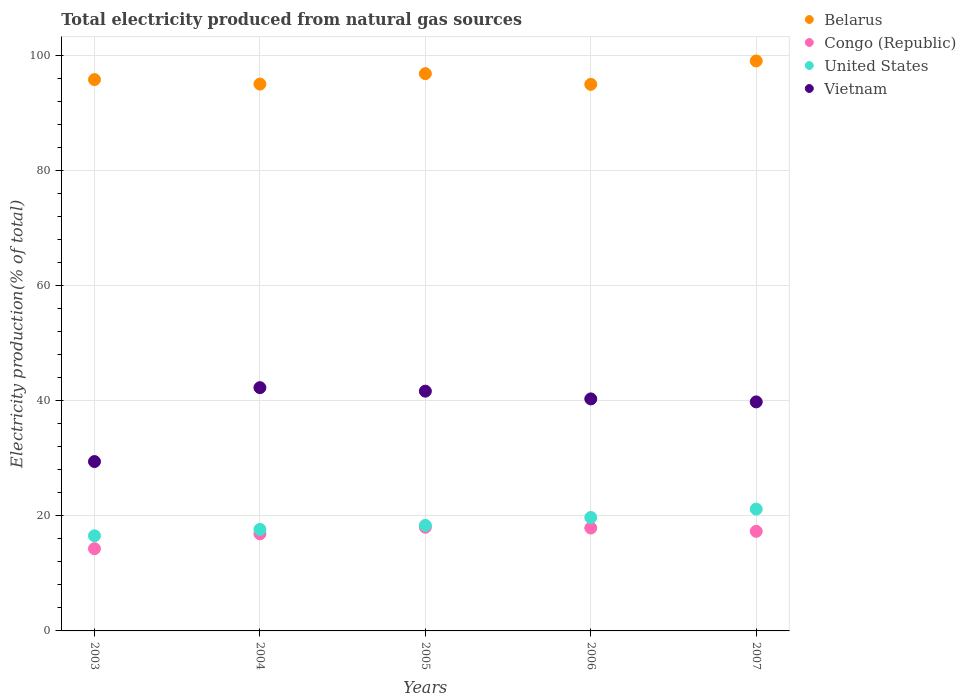Is the number of dotlines equal to the number of legend labels?
Keep it short and to the point. Yes. What is the total electricity produced in Belarus in 2006?
Ensure brevity in your answer.  94.97. Across all years, what is the maximum total electricity produced in United States?
Provide a succinct answer. 21.17. Across all years, what is the minimum total electricity produced in United States?
Your answer should be very brief. 16.53. What is the total total electricity produced in Congo (Republic) in the graph?
Your answer should be compact. 84.36. What is the difference between the total electricity produced in United States in 2006 and that in 2007?
Your answer should be very brief. -1.45. What is the difference between the total electricity produced in Congo (Republic) in 2005 and the total electricity produced in Vietnam in 2007?
Your answer should be compact. -21.78. What is the average total electricity produced in United States per year?
Your answer should be very brief. 18.68. In the year 2007, what is the difference between the total electricity produced in Congo (Republic) and total electricity produced in Belarus?
Offer a terse response. -81.73. What is the ratio of the total electricity produced in Vietnam in 2003 to that in 2007?
Make the answer very short. 0.74. Is the total electricity produced in United States in 2003 less than that in 2004?
Your response must be concise. Yes. What is the difference between the highest and the second highest total electricity produced in United States?
Ensure brevity in your answer.  1.45. What is the difference between the highest and the lowest total electricity produced in Belarus?
Your answer should be compact. 4.07. In how many years, is the total electricity produced in United States greater than the average total electricity produced in United States taken over all years?
Your response must be concise. 2. Is the sum of the total electricity produced in Belarus in 2006 and 2007 greater than the maximum total electricity produced in Vietnam across all years?
Ensure brevity in your answer.  Yes. Does the total electricity produced in Belarus monotonically increase over the years?
Offer a very short reply. No. Is the total electricity produced in Belarus strictly less than the total electricity produced in Congo (Republic) over the years?
Offer a terse response. No. How many years are there in the graph?
Keep it short and to the point. 5. What is the difference between two consecutive major ticks on the Y-axis?
Your answer should be compact. 20. Does the graph contain any zero values?
Offer a terse response. No. How many legend labels are there?
Provide a succinct answer. 4. How are the legend labels stacked?
Ensure brevity in your answer.  Vertical. What is the title of the graph?
Keep it short and to the point. Total electricity produced from natural gas sources. What is the label or title of the X-axis?
Offer a very short reply. Years. What is the label or title of the Y-axis?
Give a very brief answer. Electricity production(% of total). What is the Electricity production(% of total) in Belarus in 2003?
Your response must be concise. 95.8. What is the Electricity production(% of total) of Congo (Republic) in 2003?
Ensure brevity in your answer.  14.29. What is the Electricity production(% of total) of United States in 2003?
Provide a short and direct response. 16.53. What is the Electricity production(% of total) in Vietnam in 2003?
Ensure brevity in your answer.  29.43. What is the Electricity production(% of total) in Belarus in 2004?
Ensure brevity in your answer.  95.02. What is the Electricity production(% of total) in Congo (Republic) in 2004?
Offer a terse response. 16.88. What is the Electricity production(% of total) in United States in 2004?
Keep it short and to the point. 17.64. What is the Electricity production(% of total) of Vietnam in 2004?
Your response must be concise. 42.27. What is the Electricity production(% of total) in Belarus in 2005?
Provide a short and direct response. 96.83. What is the Electricity production(% of total) in Congo (Republic) in 2005?
Make the answer very short. 18.01. What is the Electricity production(% of total) of United States in 2005?
Your response must be concise. 18.34. What is the Electricity production(% of total) of Vietnam in 2005?
Keep it short and to the point. 41.66. What is the Electricity production(% of total) of Belarus in 2006?
Keep it short and to the point. 94.97. What is the Electricity production(% of total) of Congo (Republic) in 2006?
Offer a terse response. 17.88. What is the Electricity production(% of total) of United States in 2006?
Offer a very short reply. 19.71. What is the Electricity production(% of total) of Vietnam in 2006?
Ensure brevity in your answer.  40.32. What is the Electricity production(% of total) of Belarus in 2007?
Give a very brief answer. 99.04. What is the Electricity production(% of total) in Congo (Republic) in 2007?
Give a very brief answer. 17.31. What is the Electricity production(% of total) of United States in 2007?
Provide a succinct answer. 21.17. What is the Electricity production(% of total) of Vietnam in 2007?
Make the answer very short. 39.8. Across all years, what is the maximum Electricity production(% of total) of Belarus?
Offer a terse response. 99.04. Across all years, what is the maximum Electricity production(% of total) of Congo (Republic)?
Ensure brevity in your answer.  18.01. Across all years, what is the maximum Electricity production(% of total) in United States?
Give a very brief answer. 21.17. Across all years, what is the maximum Electricity production(% of total) of Vietnam?
Your answer should be very brief. 42.27. Across all years, what is the minimum Electricity production(% of total) of Belarus?
Your response must be concise. 94.97. Across all years, what is the minimum Electricity production(% of total) in Congo (Republic)?
Provide a short and direct response. 14.29. Across all years, what is the minimum Electricity production(% of total) of United States?
Offer a very short reply. 16.53. Across all years, what is the minimum Electricity production(% of total) of Vietnam?
Give a very brief answer. 29.43. What is the total Electricity production(% of total) in Belarus in the graph?
Provide a short and direct response. 481.67. What is the total Electricity production(% of total) of Congo (Republic) in the graph?
Ensure brevity in your answer.  84.36. What is the total Electricity production(% of total) of United States in the graph?
Offer a terse response. 93.38. What is the total Electricity production(% of total) of Vietnam in the graph?
Provide a succinct answer. 193.47. What is the difference between the Electricity production(% of total) in Belarus in 2003 and that in 2004?
Your answer should be very brief. 0.78. What is the difference between the Electricity production(% of total) of Congo (Republic) in 2003 and that in 2004?
Ensure brevity in your answer.  -2.59. What is the difference between the Electricity production(% of total) in United States in 2003 and that in 2004?
Your response must be concise. -1.11. What is the difference between the Electricity production(% of total) of Vietnam in 2003 and that in 2004?
Keep it short and to the point. -12.84. What is the difference between the Electricity production(% of total) in Belarus in 2003 and that in 2005?
Provide a short and direct response. -1.03. What is the difference between the Electricity production(% of total) in Congo (Republic) in 2003 and that in 2005?
Ensure brevity in your answer.  -3.73. What is the difference between the Electricity production(% of total) in United States in 2003 and that in 2005?
Ensure brevity in your answer.  -1.81. What is the difference between the Electricity production(% of total) of Vietnam in 2003 and that in 2005?
Ensure brevity in your answer.  -12.23. What is the difference between the Electricity production(% of total) in Belarus in 2003 and that in 2006?
Your response must be concise. 0.83. What is the difference between the Electricity production(% of total) in Congo (Republic) in 2003 and that in 2006?
Provide a succinct answer. -3.6. What is the difference between the Electricity production(% of total) in United States in 2003 and that in 2006?
Keep it short and to the point. -3.19. What is the difference between the Electricity production(% of total) in Vietnam in 2003 and that in 2006?
Keep it short and to the point. -10.89. What is the difference between the Electricity production(% of total) in Belarus in 2003 and that in 2007?
Keep it short and to the point. -3.24. What is the difference between the Electricity production(% of total) of Congo (Republic) in 2003 and that in 2007?
Ensure brevity in your answer.  -3.02. What is the difference between the Electricity production(% of total) of United States in 2003 and that in 2007?
Your answer should be compact. -4.64. What is the difference between the Electricity production(% of total) in Vietnam in 2003 and that in 2007?
Your response must be concise. -10.37. What is the difference between the Electricity production(% of total) of Belarus in 2004 and that in 2005?
Give a very brief answer. -1.81. What is the difference between the Electricity production(% of total) in Congo (Republic) in 2004 and that in 2005?
Ensure brevity in your answer.  -1.14. What is the difference between the Electricity production(% of total) in United States in 2004 and that in 2005?
Your response must be concise. -0.7. What is the difference between the Electricity production(% of total) of Vietnam in 2004 and that in 2005?
Your answer should be compact. 0.61. What is the difference between the Electricity production(% of total) of Belarus in 2004 and that in 2006?
Give a very brief answer. 0.05. What is the difference between the Electricity production(% of total) in Congo (Republic) in 2004 and that in 2006?
Your answer should be compact. -1. What is the difference between the Electricity production(% of total) of United States in 2004 and that in 2006?
Make the answer very short. -2.08. What is the difference between the Electricity production(% of total) in Vietnam in 2004 and that in 2006?
Keep it short and to the point. 1.95. What is the difference between the Electricity production(% of total) in Belarus in 2004 and that in 2007?
Make the answer very short. -4.01. What is the difference between the Electricity production(% of total) in Congo (Republic) in 2004 and that in 2007?
Provide a short and direct response. -0.43. What is the difference between the Electricity production(% of total) in United States in 2004 and that in 2007?
Offer a terse response. -3.53. What is the difference between the Electricity production(% of total) of Vietnam in 2004 and that in 2007?
Provide a succinct answer. 2.48. What is the difference between the Electricity production(% of total) of Belarus in 2005 and that in 2006?
Ensure brevity in your answer.  1.86. What is the difference between the Electricity production(% of total) of Congo (Republic) in 2005 and that in 2006?
Your answer should be very brief. 0.13. What is the difference between the Electricity production(% of total) of United States in 2005 and that in 2006?
Your answer should be compact. -1.38. What is the difference between the Electricity production(% of total) in Vietnam in 2005 and that in 2006?
Offer a very short reply. 1.34. What is the difference between the Electricity production(% of total) in Belarus in 2005 and that in 2007?
Your answer should be compact. -2.21. What is the difference between the Electricity production(% of total) in Congo (Republic) in 2005 and that in 2007?
Give a very brief answer. 0.71. What is the difference between the Electricity production(% of total) of United States in 2005 and that in 2007?
Your response must be concise. -2.83. What is the difference between the Electricity production(% of total) in Vietnam in 2005 and that in 2007?
Offer a very short reply. 1.87. What is the difference between the Electricity production(% of total) in Belarus in 2006 and that in 2007?
Keep it short and to the point. -4.07. What is the difference between the Electricity production(% of total) of Congo (Republic) in 2006 and that in 2007?
Offer a terse response. 0.57. What is the difference between the Electricity production(% of total) in United States in 2006 and that in 2007?
Provide a short and direct response. -1.45. What is the difference between the Electricity production(% of total) in Vietnam in 2006 and that in 2007?
Provide a succinct answer. 0.52. What is the difference between the Electricity production(% of total) in Belarus in 2003 and the Electricity production(% of total) in Congo (Republic) in 2004?
Provide a succinct answer. 78.92. What is the difference between the Electricity production(% of total) in Belarus in 2003 and the Electricity production(% of total) in United States in 2004?
Make the answer very short. 78.17. What is the difference between the Electricity production(% of total) of Belarus in 2003 and the Electricity production(% of total) of Vietnam in 2004?
Keep it short and to the point. 53.53. What is the difference between the Electricity production(% of total) in Congo (Republic) in 2003 and the Electricity production(% of total) in United States in 2004?
Give a very brief answer. -3.35. What is the difference between the Electricity production(% of total) in Congo (Republic) in 2003 and the Electricity production(% of total) in Vietnam in 2004?
Make the answer very short. -27.99. What is the difference between the Electricity production(% of total) in United States in 2003 and the Electricity production(% of total) in Vietnam in 2004?
Give a very brief answer. -25.74. What is the difference between the Electricity production(% of total) of Belarus in 2003 and the Electricity production(% of total) of Congo (Republic) in 2005?
Keep it short and to the point. 77.79. What is the difference between the Electricity production(% of total) in Belarus in 2003 and the Electricity production(% of total) in United States in 2005?
Provide a short and direct response. 77.46. What is the difference between the Electricity production(% of total) in Belarus in 2003 and the Electricity production(% of total) in Vietnam in 2005?
Give a very brief answer. 54.14. What is the difference between the Electricity production(% of total) in Congo (Republic) in 2003 and the Electricity production(% of total) in United States in 2005?
Make the answer very short. -4.05. What is the difference between the Electricity production(% of total) of Congo (Republic) in 2003 and the Electricity production(% of total) of Vietnam in 2005?
Offer a terse response. -27.38. What is the difference between the Electricity production(% of total) of United States in 2003 and the Electricity production(% of total) of Vietnam in 2005?
Provide a succinct answer. -25.13. What is the difference between the Electricity production(% of total) in Belarus in 2003 and the Electricity production(% of total) in Congo (Republic) in 2006?
Offer a very short reply. 77.92. What is the difference between the Electricity production(% of total) in Belarus in 2003 and the Electricity production(% of total) in United States in 2006?
Offer a terse response. 76.09. What is the difference between the Electricity production(% of total) in Belarus in 2003 and the Electricity production(% of total) in Vietnam in 2006?
Offer a very short reply. 55.48. What is the difference between the Electricity production(% of total) in Congo (Republic) in 2003 and the Electricity production(% of total) in United States in 2006?
Ensure brevity in your answer.  -5.43. What is the difference between the Electricity production(% of total) in Congo (Republic) in 2003 and the Electricity production(% of total) in Vietnam in 2006?
Give a very brief answer. -26.03. What is the difference between the Electricity production(% of total) in United States in 2003 and the Electricity production(% of total) in Vietnam in 2006?
Your answer should be compact. -23.79. What is the difference between the Electricity production(% of total) in Belarus in 2003 and the Electricity production(% of total) in Congo (Republic) in 2007?
Ensure brevity in your answer.  78.49. What is the difference between the Electricity production(% of total) in Belarus in 2003 and the Electricity production(% of total) in United States in 2007?
Offer a very short reply. 74.64. What is the difference between the Electricity production(% of total) of Belarus in 2003 and the Electricity production(% of total) of Vietnam in 2007?
Keep it short and to the point. 56.01. What is the difference between the Electricity production(% of total) in Congo (Republic) in 2003 and the Electricity production(% of total) in United States in 2007?
Your response must be concise. -6.88. What is the difference between the Electricity production(% of total) in Congo (Republic) in 2003 and the Electricity production(% of total) in Vietnam in 2007?
Keep it short and to the point. -25.51. What is the difference between the Electricity production(% of total) of United States in 2003 and the Electricity production(% of total) of Vietnam in 2007?
Provide a succinct answer. -23.27. What is the difference between the Electricity production(% of total) in Belarus in 2004 and the Electricity production(% of total) in Congo (Republic) in 2005?
Keep it short and to the point. 77.01. What is the difference between the Electricity production(% of total) of Belarus in 2004 and the Electricity production(% of total) of United States in 2005?
Provide a short and direct response. 76.69. What is the difference between the Electricity production(% of total) in Belarus in 2004 and the Electricity production(% of total) in Vietnam in 2005?
Keep it short and to the point. 53.36. What is the difference between the Electricity production(% of total) of Congo (Republic) in 2004 and the Electricity production(% of total) of United States in 2005?
Give a very brief answer. -1.46. What is the difference between the Electricity production(% of total) of Congo (Republic) in 2004 and the Electricity production(% of total) of Vietnam in 2005?
Offer a terse response. -24.79. What is the difference between the Electricity production(% of total) of United States in 2004 and the Electricity production(% of total) of Vietnam in 2005?
Offer a very short reply. -24.03. What is the difference between the Electricity production(% of total) of Belarus in 2004 and the Electricity production(% of total) of Congo (Republic) in 2006?
Offer a very short reply. 77.14. What is the difference between the Electricity production(% of total) in Belarus in 2004 and the Electricity production(% of total) in United States in 2006?
Make the answer very short. 75.31. What is the difference between the Electricity production(% of total) in Belarus in 2004 and the Electricity production(% of total) in Vietnam in 2006?
Offer a terse response. 54.71. What is the difference between the Electricity production(% of total) in Congo (Republic) in 2004 and the Electricity production(% of total) in United States in 2006?
Offer a very short reply. -2.84. What is the difference between the Electricity production(% of total) in Congo (Republic) in 2004 and the Electricity production(% of total) in Vietnam in 2006?
Provide a short and direct response. -23.44. What is the difference between the Electricity production(% of total) in United States in 2004 and the Electricity production(% of total) in Vietnam in 2006?
Provide a succinct answer. -22.68. What is the difference between the Electricity production(% of total) of Belarus in 2004 and the Electricity production(% of total) of Congo (Republic) in 2007?
Make the answer very short. 77.72. What is the difference between the Electricity production(% of total) in Belarus in 2004 and the Electricity production(% of total) in United States in 2007?
Provide a succinct answer. 73.86. What is the difference between the Electricity production(% of total) in Belarus in 2004 and the Electricity production(% of total) in Vietnam in 2007?
Offer a very short reply. 55.23. What is the difference between the Electricity production(% of total) in Congo (Republic) in 2004 and the Electricity production(% of total) in United States in 2007?
Make the answer very short. -4.29. What is the difference between the Electricity production(% of total) of Congo (Republic) in 2004 and the Electricity production(% of total) of Vietnam in 2007?
Your response must be concise. -22.92. What is the difference between the Electricity production(% of total) in United States in 2004 and the Electricity production(% of total) in Vietnam in 2007?
Offer a very short reply. -22.16. What is the difference between the Electricity production(% of total) of Belarus in 2005 and the Electricity production(% of total) of Congo (Republic) in 2006?
Your answer should be compact. 78.95. What is the difference between the Electricity production(% of total) of Belarus in 2005 and the Electricity production(% of total) of United States in 2006?
Your answer should be very brief. 77.12. What is the difference between the Electricity production(% of total) of Belarus in 2005 and the Electricity production(% of total) of Vietnam in 2006?
Your response must be concise. 56.51. What is the difference between the Electricity production(% of total) of Congo (Republic) in 2005 and the Electricity production(% of total) of United States in 2006?
Provide a short and direct response. -1.7. What is the difference between the Electricity production(% of total) of Congo (Republic) in 2005 and the Electricity production(% of total) of Vietnam in 2006?
Make the answer very short. -22.3. What is the difference between the Electricity production(% of total) of United States in 2005 and the Electricity production(% of total) of Vietnam in 2006?
Your response must be concise. -21.98. What is the difference between the Electricity production(% of total) of Belarus in 2005 and the Electricity production(% of total) of Congo (Republic) in 2007?
Make the answer very short. 79.52. What is the difference between the Electricity production(% of total) in Belarus in 2005 and the Electricity production(% of total) in United States in 2007?
Ensure brevity in your answer.  75.67. What is the difference between the Electricity production(% of total) in Belarus in 2005 and the Electricity production(% of total) in Vietnam in 2007?
Provide a succinct answer. 57.04. What is the difference between the Electricity production(% of total) of Congo (Republic) in 2005 and the Electricity production(% of total) of United States in 2007?
Ensure brevity in your answer.  -3.15. What is the difference between the Electricity production(% of total) of Congo (Republic) in 2005 and the Electricity production(% of total) of Vietnam in 2007?
Provide a short and direct response. -21.78. What is the difference between the Electricity production(% of total) in United States in 2005 and the Electricity production(% of total) in Vietnam in 2007?
Your answer should be compact. -21.46. What is the difference between the Electricity production(% of total) of Belarus in 2006 and the Electricity production(% of total) of Congo (Republic) in 2007?
Provide a short and direct response. 77.67. What is the difference between the Electricity production(% of total) of Belarus in 2006 and the Electricity production(% of total) of United States in 2007?
Offer a terse response. 73.81. What is the difference between the Electricity production(% of total) of Belarus in 2006 and the Electricity production(% of total) of Vietnam in 2007?
Provide a short and direct response. 55.18. What is the difference between the Electricity production(% of total) of Congo (Republic) in 2006 and the Electricity production(% of total) of United States in 2007?
Give a very brief answer. -3.29. What is the difference between the Electricity production(% of total) in Congo (Republic) in 2006 and the Electricity production(% of total) in Vietnam in 2007?
Your answer should be very brief. -21.91. What is the difference between the Electricity production(% of total) of United States in 2006 and the Electricity production(% of total) of Vietnam in 2007?
Give a very brief answer. -20.08. What is the average Electricity production(% of total) of Belarus per year?
Offer a very short reply. 96.33. What is the average Electricity production(% of total) in Congo (Republic) per year?
Keep it short and to the point. 16.87. What is the average Electricity production(% of total) of United States per year?
Provide a succinct answer. 18.68. What is the average Electricity production(% of total) in Vietnam per year?
Make the answer very short. 38.69. In the year 2003, what is the difference between the Electricity production(% of total) of Belarus and Electricity production(% of total) of Congo (Republic)?
Your response must be concise. 81.52. In the year 2003, what is the difference between the Electricity production(% of total) in Belarus and Electricity production(% of total) in United States?
Provide a succinct answer. 79.27. In the year 2003, what is the difference between the Electricity production(% of total) of Belarus and Electricity production(% of total) of Vietnam?
Offer a terse response. 66.37. In the year 2003, what is the difference between the Electricity production(% of total) of Congo (Republic) and Electricity production(% of total) of United States?
Your response must be concise. -2.24. In the year 2003, what is the difference between the Electricity production(% of total) in Congo (Republic) and Electricity production(% of total) in Vietnam?
Offer a very short reply. -15.14. In the year 2003, what is the difference between the Electricity production(% of total) of United States and Electricity production(% of total) of Vietnam?
Provide a succinct answer. -12.9. In the year 2004, what is the difference between the Electricity production(% of total) in Belarus and Electricity production(% of total) in Congo (Republic)?
Provide a short and direct response. 78.15. In the year 2004, what is the difference between the Electricity production(% of total) in Belarus and Electricity production(% of total) in United States?
Offer a very short reply. 77.39. In the year 2004, what is the difference between the Electricity production(% of total) in Belarus and Electricity production(% of total) in Vietnam?
Make the answer very short. 52.75. In the year 2004, what is the difference between the Electricity production(% of total) of Congo (Republic) and Electricity production(% of total) of United States?
Provide a short and direct response. -0.76. In the year 2004, what is the difference between the Electricity production(% of total) in Congo (Republic) and Electricity production(% of total) in Vietnam?
Your answer should be compact. -25.39. In the year 2004, what is the difference between the Electricity production(% of total) of United States and Electricity production(% of total) of Vietnam?
Ensure brevity in your answer.  -24.64. In the year 2005, what is the difference between the Electricity production(% of total) of Belarus and Electricity production(% of total) of Congo (Republic)?
Ensure brevity in your answer.  78.82. In the year 2005, what is the difference between the Electricity production(% of total) in Belarus and Electricity production(% of total) in United States?
Your answer should be compact. 78.49. In the year 2005, what is the difference between the Electricity production(% of total) in Belarus and Electricity production(% of total) in Vietnam?
Your response must be concise. 55.17. In the year 2005, what is the difference between the Electricity production(% of total) in Congo (Republic) and Electricity production(% of total) in United States?
Ensure brevity in your answer.  -0.32. In the year 2005, what is the difference between the Electricity production(% of total) in Congo (Republic) and Electricity production(% of total) in Vietnam?
Your answer should be very brief. -23.65. In the year 2005, what is the difference between the Electricity production(% of total) of United States and Electricity production(% of total) of Vietnam?
Offer a very short reply. -23.32. In the year 2006, what is the difference between the Electricity production(% of total) in Belarus and Electricity production(% of total) in Congo (Republic)?
Offer a terse response. 77.09. In the year 2006, what is the difference between the Electricity production(% of total) in Belarus and Electricity production(% of total) in United States?
Keep it short and to the point. 75.26. In the year 2006, what is the difference between the Electricity production(% of total) of Belarus and Electricity production(% of total) of Vietnam?
Provide a succinct answer. 54.66. In the year 2006, what is the difference between the Electricity production(% of total) in Congo (Republic) and Electricity production(% of total) in United States?
Provide a short and direct response. -1.83. In the year 2006, what is the difference between the Electricity production(% of total) of Congo (Republic) and Electricity production(% of total) of Vietnam?
Keep it short and to the point. -22.44. In the year 2006, what is the difference between the Electricity production(% of total) of United States and Electricity production(% of total) of Vietnam?
Ensure brevity in your answer.  -20.6. In the year 2007, what is the difference between the Electricity production(% of total) in Belarus and Electricity production(% of total) in Congo (Republic)?
Keep it short and to the point. 81.73. In the year 2007, what is the difference between the Electricity production(% of total) in Belarus and Electricity production(% of total) in United States?
Offer a terse response. 77.87. In the year 2007, what is the difference between the Electricity production(% of total) of Belarus and Electricity production(% of total) of Vietnam?
Give a very brief answer. 59.24. In the year 2007, what is the difference between the Electricity production(% of total) of Congo (Republic) and Electricity production(% of total) of United States?
Provide a short and direct response. -3.86. In the year 2007, what is the difference between the Electricity production(% of total) in Congo (Republic) and Electricity production(% of total) in Vietnam?
Provide a succinct answer. -22.49. In the year 2007, what is the difference between the Electricity production(% of total) in United States and Electricity production(% of total) in Vietnam?
Your response must be concise. -18.63. What is the ratio of the Electricity production(% of total) of Belarus in 2003 to that in 2004?
Your answer should be very brief. 1.01. What is the ratio of the Electricity production(% of total) of Congo (Republic) in 2003 to that in 2004?
Provide a short and direct response. 0.85. What is the ratio of the Electricity production(% of total) of United States in 2003 to that in 2004?
Offer a terse response. 0.94. What is the ratio of the Electricity production(% of total) of Vietnam in 2003 to that in 2004?
Provide a short and direct response. 0.7. What is the ratio of the Electricity production(% of total) in Belarus in 2003 to that in 2005?
Your answer should be very brief. 0.99. What is the ratio of the Electricity production(% of total) in Congo (Republic) in 2003 to that in 2005?
Make the answer very short. 0.79. What is the ratio of the Electricity production(% of total) of United States in 2003 to that in 2005?
Offer a very short reply. 0.9. What is the ratio of the Electricity production(% of total) in Vietnam in 2003 to that in 2005?
Make the answer very short. 0.71. What is the ratio of the Electricity production(% of total) in Belarus in 2003 to that in 2006?
Your answer should be very brief. 1.01. What is the ratio of the Electricity production(% of total) of Congo (Republic) in 2003 to that in 2006?
Your answer should be compact. 0.8. What is the ratio of the Electricity production(% of total) of United States in 2003 to that in 2006?
Give a very brief answer. 0.84. What is the ratio of the Electricity production(% of total) in Vietnam in 2003 to that in 2006?
Keep it short and to the point. 0.73. What is the ratio of the Electricity production(% of total) in Belarus in 2003 to that in 2007?
Offer a very short reply. 0.97. What is the ratio of the Electricity production(% of total) in Congo (Republic) in 2003 to that in 2007?
Ensure brevity in your answer.  0.83. What is the ratio of the Electricity production(% of total) in United States in 2003 to that in 2007?
Ensure brevity in your answer.  0.78. What is the ratio of the Electricity production(% of total) of Vietnam in 2003 to that in 2007?
Provide a succinct answer. 0.74. What is the ratio of the Electricity production(% of total) in Belarus in 2004 to that in 2005?
Make the answer very short. 0.98. What is the ratio of the Electricity production(% of total) in Congo (Republic) in 2004 to that in 2005?
Offer a very short reply. 0.94. What is the ratio of the Electricity production(% of total) in United States in 2004 to that in 2005?
Keep it short and to the point. 0.96. What is the ratio of the Electricity production(% of total) in Vietnam in 2004 to that in 2005?
Offer a very short reply. 1.01. What is the ratio of the Electricity production(% of total) in Congo (Republic) in 2004 to that in 2006?
Offer a very short reply. 0.94. What is the ratio of the Electricity production(% of total) of United States in 2004 to that in 2006?
Your answer should be very brief. 0.89. What is the ratio of the Electricity production(% of total) in Vietnam in 2004 to that in 2006?
Make the answer very short. 1.05. What is the ratio of the Electricity production(% of total) in Belarus in 2004 to that in 2007?
Give a very brief answer. 0.96. What is the ratio of the Electricity production(% of total) in Congo (Republic) in 2004 to that in 2007?
Offer a very short reply. 0.98. What is the ratio of the Electricity production(% of total) in United States in 2004 to that in 2007?
Your response must be concise. 0.83. What is the ratio of the Electricity production(% of total) of Vietnam in 2004 to that in 2007?
Give a very brief answer. 1.06. What is the ratio of the Electricity production(% of total) of Belarus in 2005 to that in 2006?
Offer a terse response. 1.02. What is the ratio of the Electricity production(% of total) of Congo (Republic) in 2005 to that in 2006?
Your answer should be compact. 1.01. What is the ratio of the Electricity production(% of total) of United States in 2005 to that in 2006?
Keep it short and to the point. 0.93. What is the ratio of the Electricity production(% of total) of Vietnam in 2005 to that in 2006?
Your response must be concise. 1.03. What is the ratio of the Electricity production(% of total) of Belarus in 2005 to that in 2007?
Your answer should be very brief. 0.98. What is the ratio of the Electricity production(% of total) of Congo (Republic) in 2005 to that in 2007?
Offer a terse response. 1.04. What is the ratio of the Electricity production(% of total) in United States in 2005 to that in 2007?
Offer a terse response. 0.87. What is the ratio of the Electricity production(% of total) in Vietnam in 2005 to that in 2007?
Make the answer very short. 1.05. What is the ratio of the Electricity production(% of total) of Congo (Republic) in 2006 to that in 2007?
Keep it short and to the point. 1.03. What is the ratio of the Electricity production(% of total) of United States in 2006 to that in 2007?
Offer a very short reply. 0.93. What is the ratio of the Electricity production(% of total) in Vietnam in 2006 to that in 2007?
Give a very brief answer. 1.01. What is the difference between the highest and the second highest Electricity production(% of total) of Belarus?
Your answer should be compact. 2.21. What is the difference between the highest and the second highest Electricity production(% of total) of Congo (Republic)?
Give a very brief answer. 0.13. What is the difference between the highest and the second highest Electricity production(% of total) of United States?
Give a very brief answer. 1.45. What is the difference between the highest and the second highest Electricity production(% of total) of Vietnam?
Provide a succinct answer. 0.61. What is the difference between the highest and the lowest Electricity production(% of total) in Belarus?
Your answer should be compact. 4.07. What is the difference between the highest and the lowest Electricity production(% of total) in Congo (Republic)?
Offer a terse response. 3.73. What is the difference between the highest and the lowest Electricity production(% of total) in United States?
Offer a terse response. 4.64. What is the difference between the highest and the lowest Electricity production(% of total) of Vietnam?
Keep it short and to the point. 12.84. 